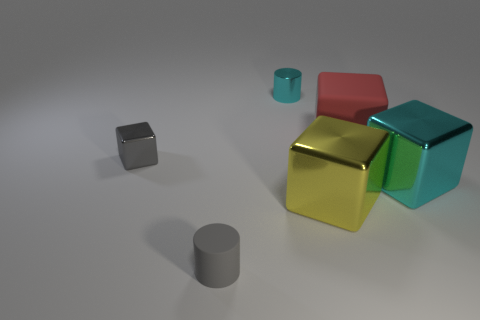Add 4 yellow cubes. How many objects exist? 10 Subtract all metallic cubes. How many cubes are left? 1 Subtract 2 cylinders. How many cylinders are left? 0 Subtract all cyan cylinders. How many cylinders are left? 1 Subtract all blue cubes. Subtract all gray spheres. How many cubes are left? 4 Subtract all blue blocks. How many yellow cylinders are left? 0 Subtract all tiny gray blocks. Subtract all gray rubber things. How many objects are left? 4 Add 6 yellow things. How many yellow things are left? 7 Add 1 big blue shiny balls. How many big blue shiny balls exist? 1 Subtract 0 green blocks. How many objects are left? 6 